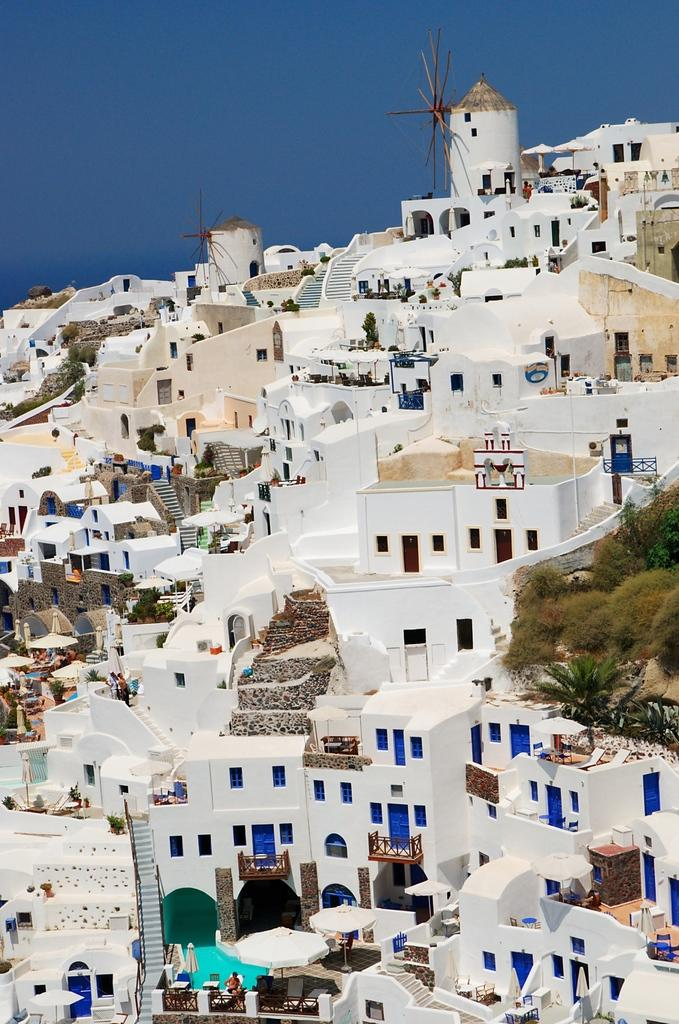What types of structures are visible in the image? There are buildings in the image. Who or what else can be seen in the image? There are people and trees visible in the image. Can you describe any other elements in the image? There are objects in the image. What can be seen in the background of the image? The sky is visible in the background of the image. Are there any visitors crying in the image? There is no mention of visitors or crying in the image; it only features buildings, people, trees, objects, and the sky. 